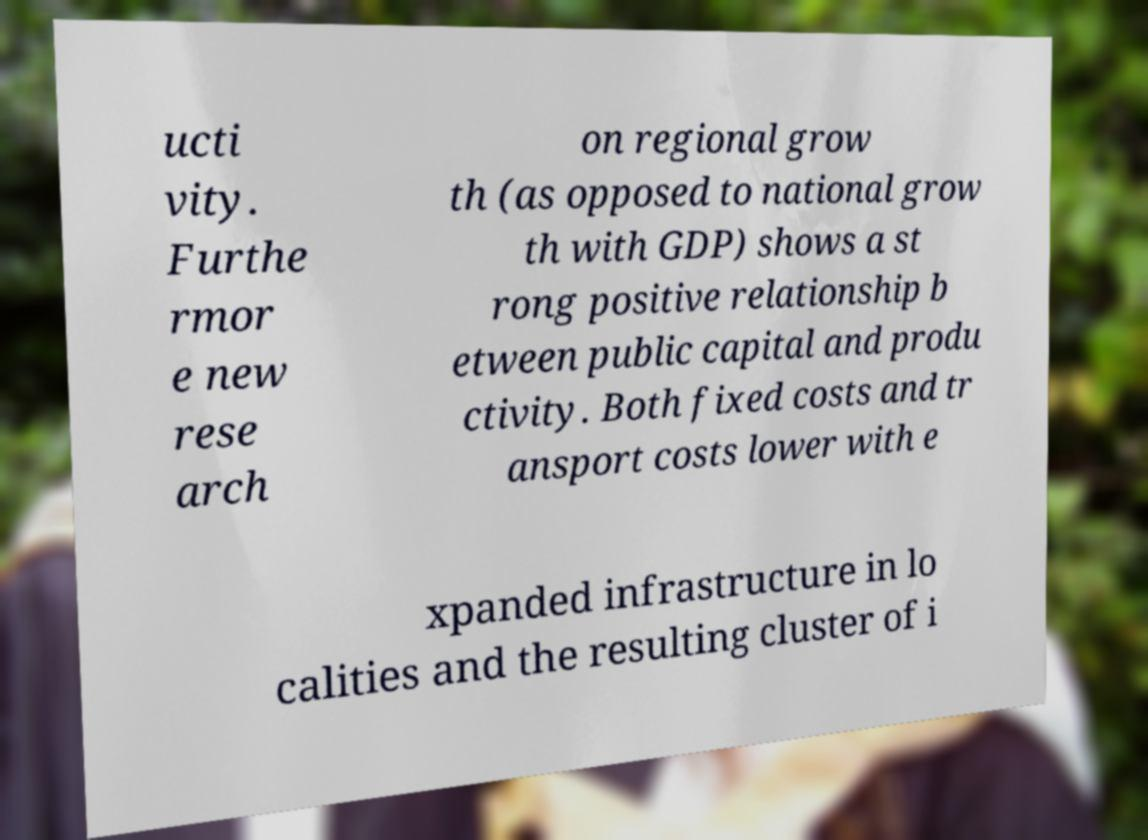Could you assist in decoding the text presented in this image and type it out clearly? ucti vity. Furthe rmor e new rese arch on regional grow th (as opposed to national grow th with GDP) shows a st rong positive relationship b etween public capital and produ ctivity. Both fixed costs and tr ansport costs lower with e xpanded infrastructure in lo calities and the resulting cluster of i 